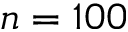Convert formula to latex. <formula><loc_0><loc_0><loc_500><loc_500>n = 1 0 0</formula> 